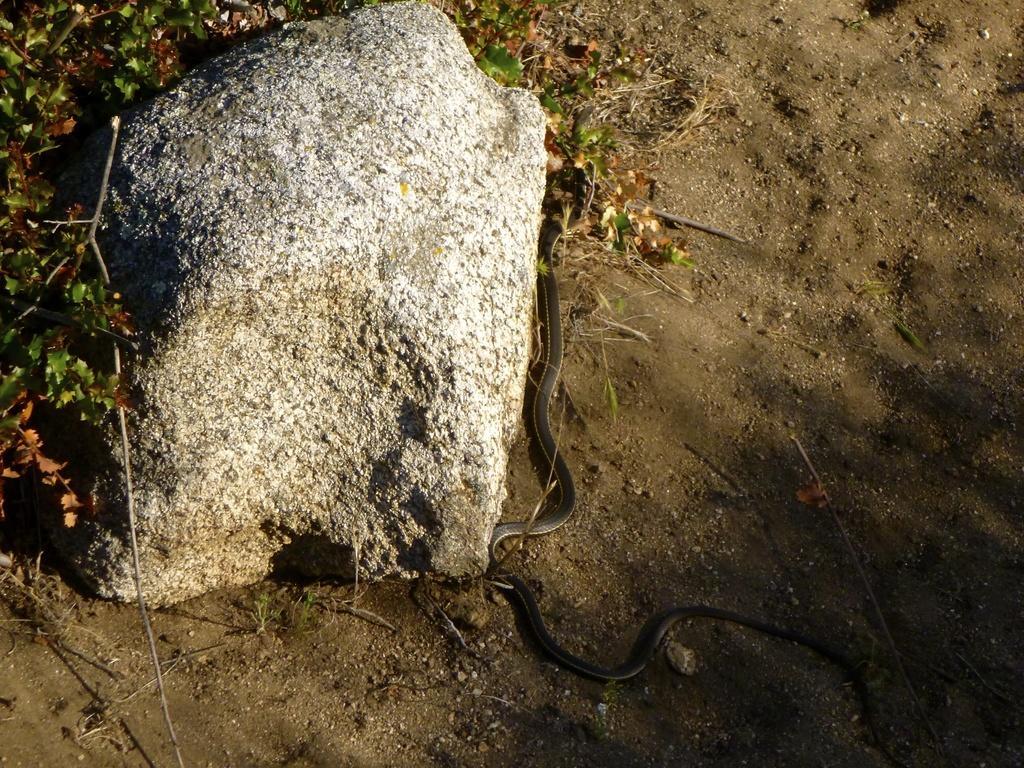Please provide a concise description of this image. In this picture we can see a snake on the path and on the right side of the snake there is a rock and plants. 